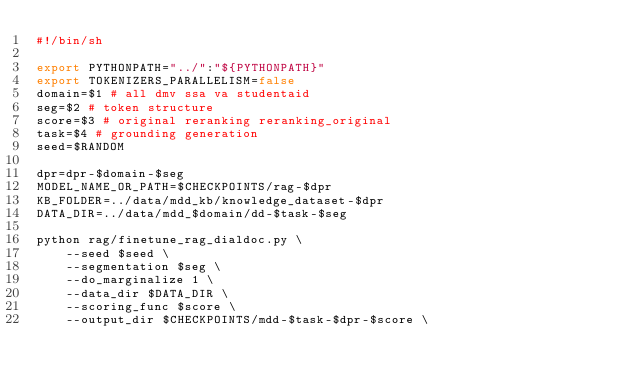<code> <loc_0><loc_0><loc_500><loc_500><_Bash_>#!/bin/sh

export PYTHONPATH="../":"${PYTHONPATH}"
export TOKENIZERS_PARALLELISM=false
domain=$1 # all dmv ssa va studentaid
seg=$2 # token structure
score=$3 # original reranking reranking_original
task=$4 # grounding generation
seed=$RANDOM 

dpr=dpr-$domain-$seg
MODEL_NAME_OR_PATH=$CHECKPOINTS/rag-$dpr
KB_FOLDER=../data/mdd_kb/knowledge_dataset-$dpr
DATA_DIR=../data/mdd_$domain/dd-$task-$seg

python rag/finetune_rag_dialdoc.py \
    --seed $seed \
    --segmentation $seg \
    --do_marginalize 1 \
    --data_dir $DATA_DIR \
    --scoring_func $score \
    --output_dir $CHECKPOINTS/mdd-$task-$dpr-$score \</code> 